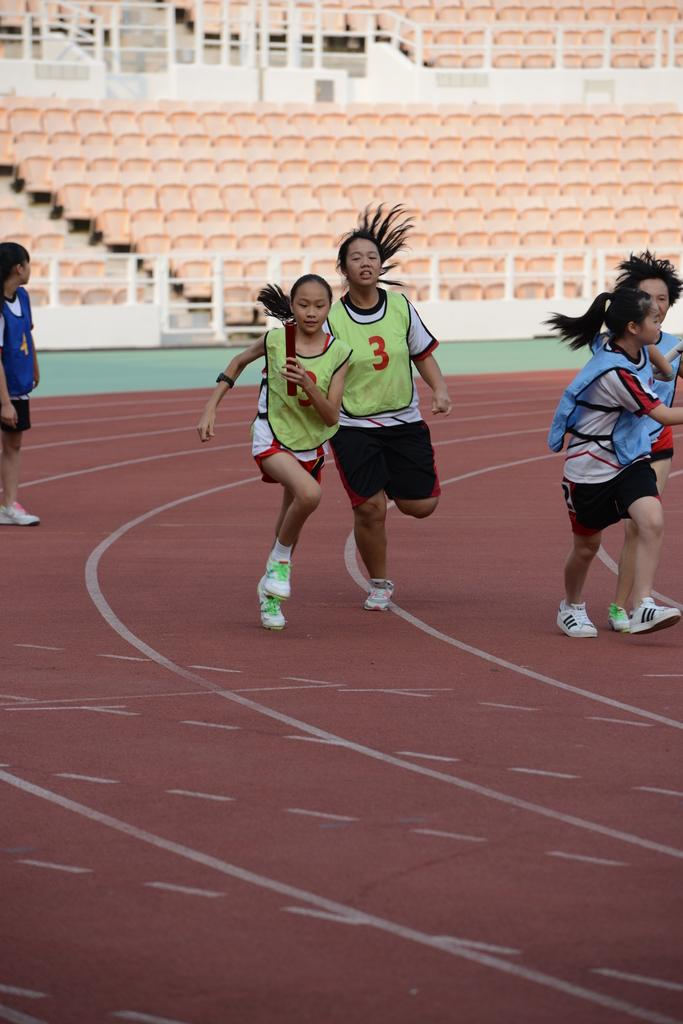What are the people in the image doing? The people in the image are running. Can you describe the person on the left side of the image? There is a person standing on the left side of the image. What can be seen in the background of the image? There are chairs visible in the background of the image. What feature is present that might be used for support or safety? There is railing visible in the image. Where is the donkey located in the image? There is no donkey present in the image. What type of ball is being used by the people running in the image? The people running in the image are not using any balls; they are simply running. 